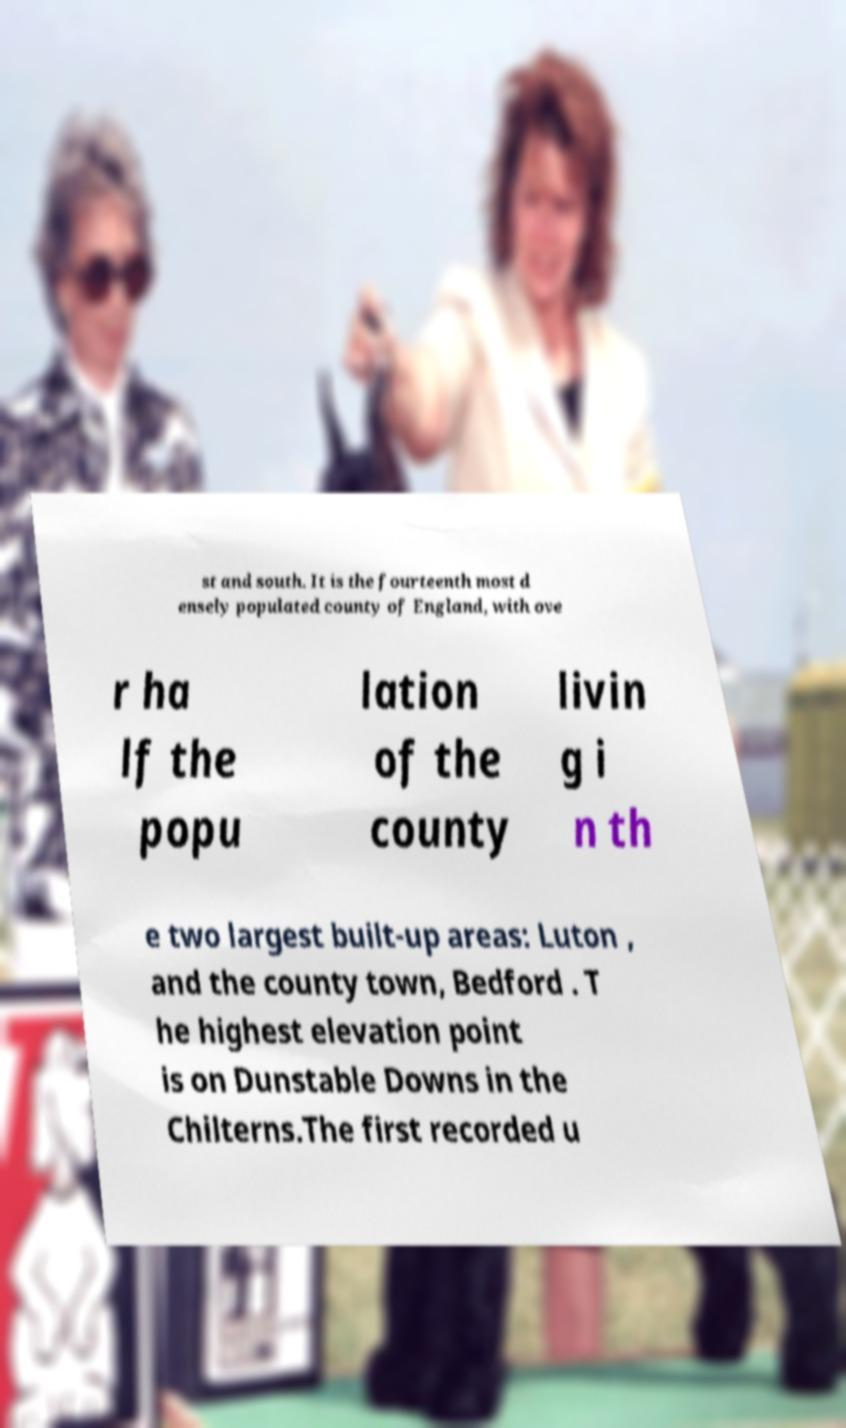Please identify and transcribe the text found in this image. st and south. It is the fourteenth most d ensely populated county of England, with ove r ha lf the popu lation of the county livin g i n th e two largest built-up areas: Luton , and the county town, Bedford . T he highest elevation point is on Dunstable Downs in the Chilterns.The first recorded u 